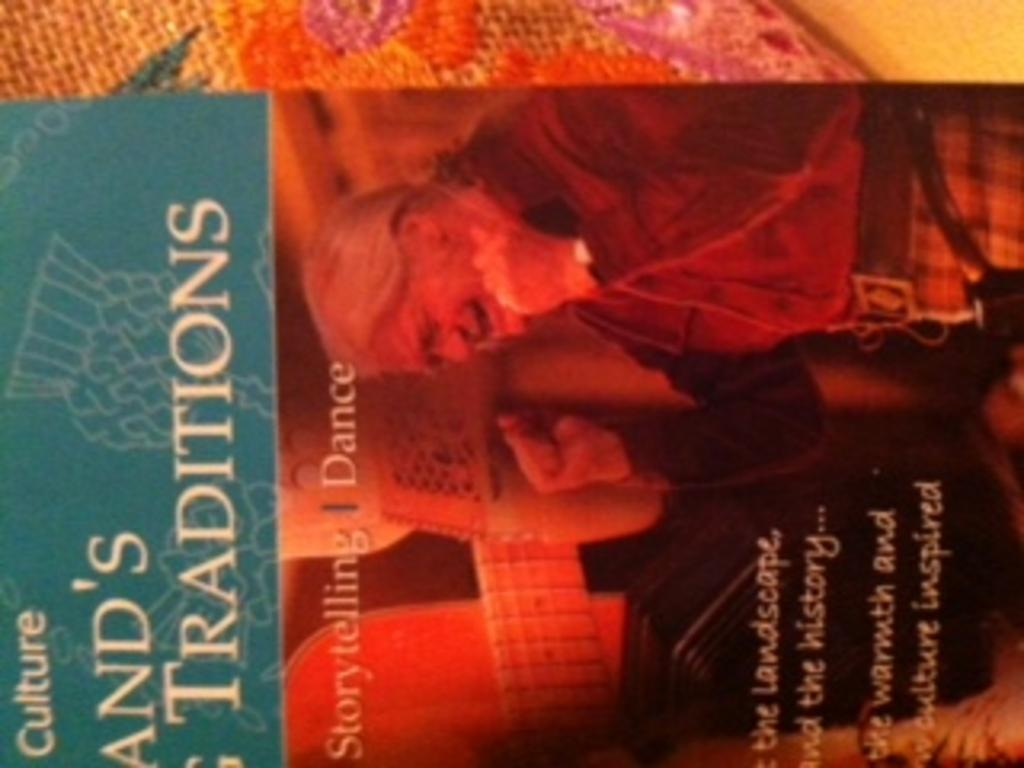Provide a one-sentence caption for the provided image. A book that talks about traditions of storytelling and dance. 